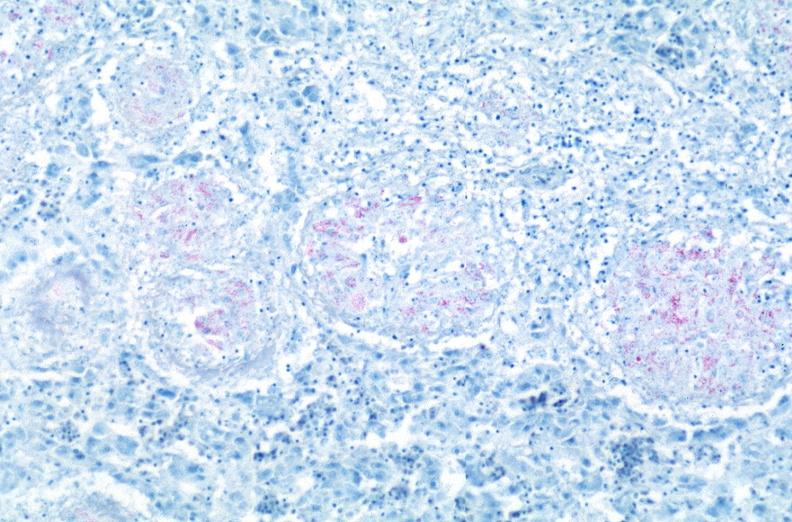s respiratory present?
Answer the question using a single word or phrase. Yes 